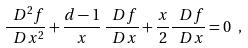<formula> <loc_0><loc_0><loc_500><loc_500>\frac { \ D ^ { 2 } f } { \ D x ^ { 2 } } + \frac { d - 1 } { x } \, \frac { \ D f } { \ D x } + \frac { x } { 2 } \frac { \ D f } { \ D x } = 0 \ ,</formula> 